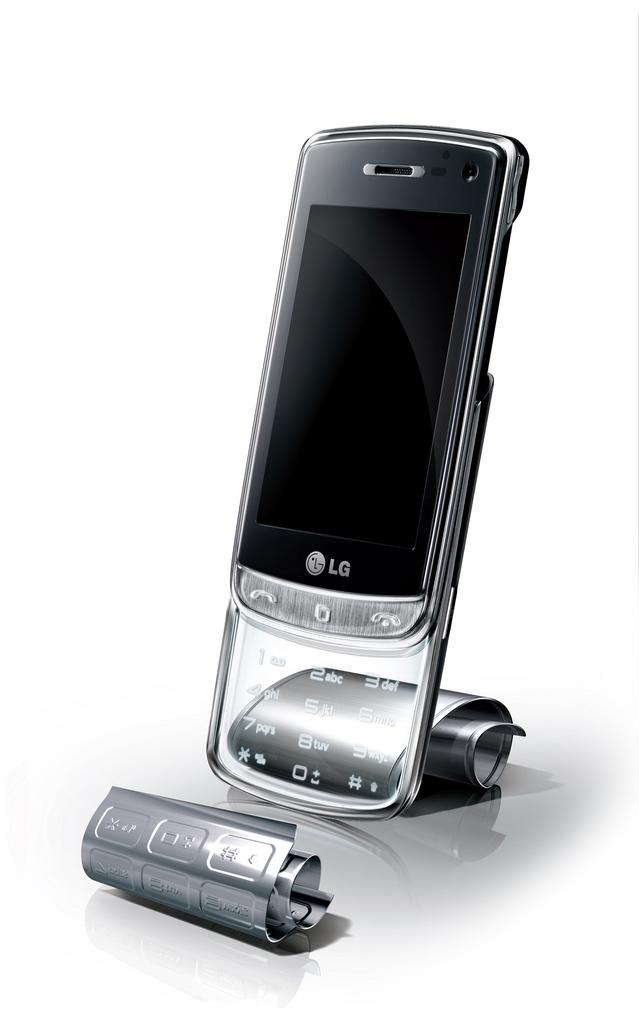What electronic device is visible in the image? There is a mobile phone in the image. What feature of the mobile phone allows for input? The mobile phone has buttons for input. What material is used for the exterior of the mobile phone? There are metal sheets on the mobile phone. What can be seen on the front of the mobile phone? There is a screen on the mobile phone. What color is the background of the image? The background of the image appears to be white. What type of flesh can be seen on the mobile phone in the image? There is no flesh present on the mobile phone in the image; it is an electronic device made of metal sheets and other materials. 